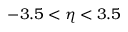<formula> <loc_0><loc_0><loc_500><loc_500>- 3 . 5 < \eta < 3 . 5</formula> 